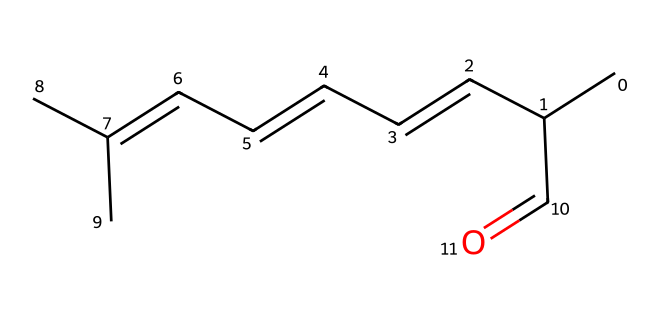What is the molecular formula of this chemical? To find the molecular formula, count the number of carbon (C), hydrogen (H), and oxygen (O) atoms from the chemical structure. There are 15 carbons, 26 hydrogens, and 1 oxygen, resulting in the formula C15H26O.
Answer: C15H26O How many double bonds are present in this structure? Examine the chemical structure for any double bonds between atoms. There are a total of two double bonds in the structure, one located between the carbon atoms in the side chain and another between the carbon and oxygen atom.
Answer: 2 What type of functional group is indicated by the presence of the carbonyl (C=O) in this structure? The presence of a carbonyl group (C=O) indicates that this chemical belongs to the aldehyde family, as it is located at the end of a carbon chain.
Answer: aldehyde Is this chemical likely to be soluble in water or oil? Analyze the chemical structure: the long carbon chain and the presence of the hydrophobic carbon atoms suggest that it is more nonpolar, indicating it would be soluble in oil rather than water.
Answer: oil Does this chemical have potential insect-repelling properties based on its structure? Considering the compound's structure, such as the long alkyl chain and the carbonyl group, it likely has versatile interactions that can disrupt insect olfactory receptors, indicating potential insect-repelling properties.
Answer: yes What is the primary use of this chemical in a coastal hotel environment? Given its structure and chemical properties, this compound can be utilized primarily as a natural insect repellent to enhance the comfort of guests in coastal settings.
Answer: insect repellent 